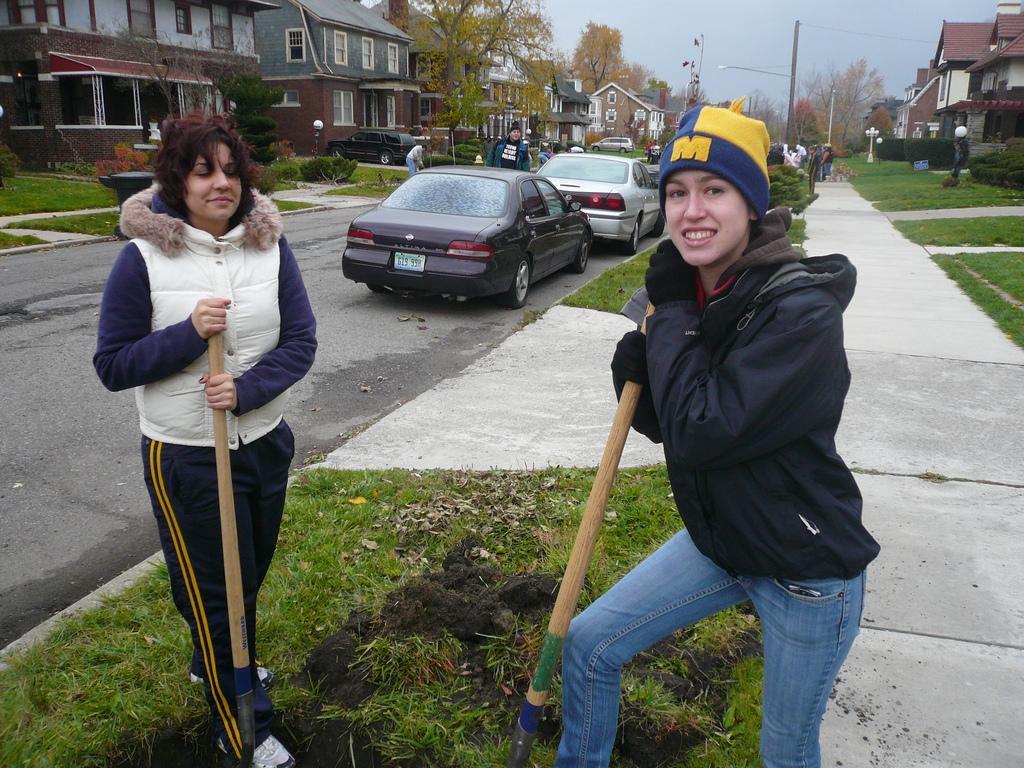In one or two sentences, can you explain what this image depicts? In this image we can see two women are standing and holding wooden bamboo in their hand. One woman is wearing black jacket with jeans and the other one is wearing white jacket and track. Behind them cars are present on the road. To the both sides of the image buildings, trees and poles are there. In front of the buildings grassy lands are present. 